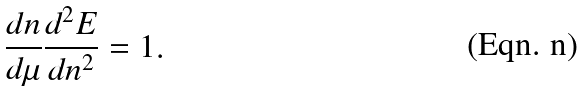<formula> <loc_0><loc_0><loc_500><loc_500>\frac { d n } { d \mu } \frac { d ^ { 2 } E } { d n ^ { 2 } } = 1 .</formula> 